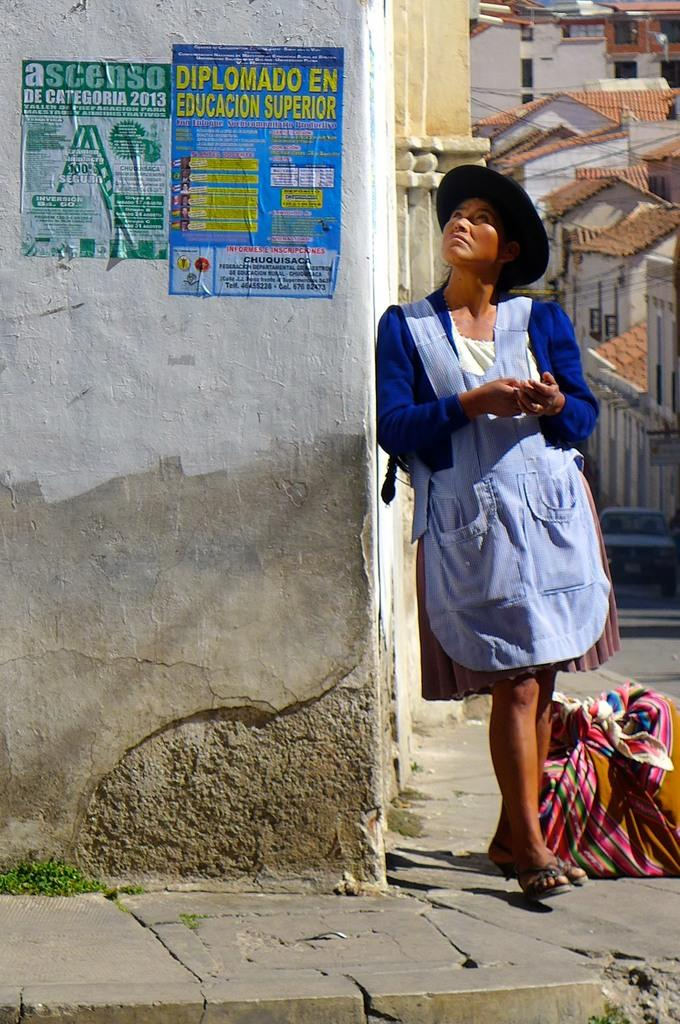What is on the wall in the image? There are posters on the wall in the image. Can you describe the person standing beside the wall? A person is standing beside the wall in the image. What can be seen in the distance in the image? There are buildings visible far away in the image. How many chairs are visible in the image? There are no chairs visible in the image. What emotion is the person beside the wall feeling in the image? The emotion of the person beside the wall cannot be determined from the image. 